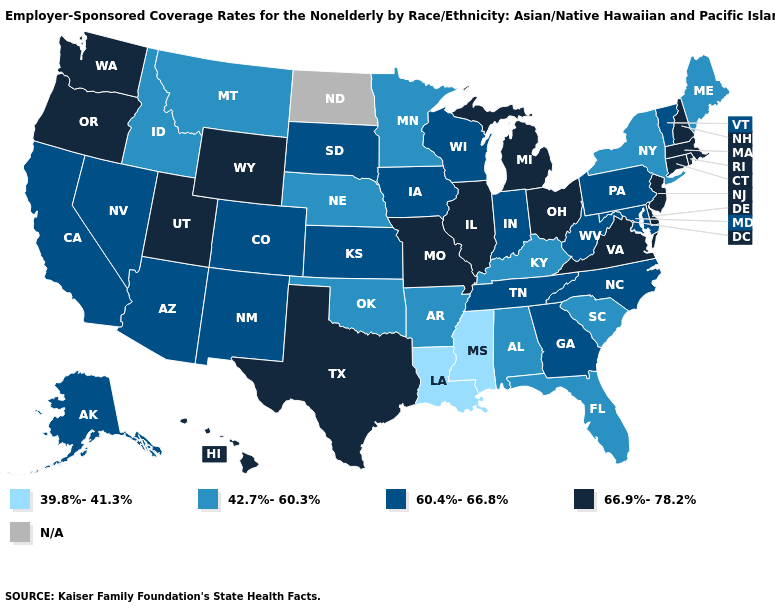Which states have the lowest value in the West?
Give a very brief answer. Idaho, Montana. What is the value of Pennsylvania?
Write a very short answer. 60.4%-66.8%. Name the states that have a value in the range 66.9%-78.2%?
Write a very short answer. Connecticut, Delaware, Hawaii, Illinois, Massachusetts, Michigan, Missouri, New Hampshire, New Jersey, Ohio, Oregon, Rhode Island, Texas, Utah, Virginia, Washington, Wyoming. What is the value of Arkansas?
Quick response, please. 42.7%-60.3%. Does the first symbol in the legend represent the smallest category?
Keep it brief. Yes. Name the states that have a value in the range 39.8%-41.3%?
Keep it brief. Louisiana, Mississippi. What is the value of New Hampshire?
Answer briefly. 66.9%-78.2%. Does Louisiana have the lowest value in the USA?
Write a very short answer. Yes. Name the states that have a value in the range 60.4%-66.8%?
Write a very short answer. Alaska, Arizona, California, Colorado, Georgia, Indiana, Iowa, Kansas, Maryland, Nevada, New Mexico, North Carolina, Pennsylvania, South Dakota, Tennessee, Vermont, West Virginia, Wisconsin. What is the value of Minnesota?
Answer briefly. 42.7%-60.3%. Name the states that have a value in the range N/A?
Write a very short answer. North Dakota. What is the value of Illinois?
Concise answer only. 66.9%-78.2%. Does New Jersey have the highest value in the USA?
Give a very brief answer. Yes. Name the states that have a value in the range 66.9%-78.2%?
Be succinct. Connecticut, Delaware, Hawaii, Illinois, Massachusetts, Michigan, Missouri, New Hampshire, New Jersey, Ohio, Oregon, Rhode Island, Texas, Utah, Virginia, Washington, Wyoming. 